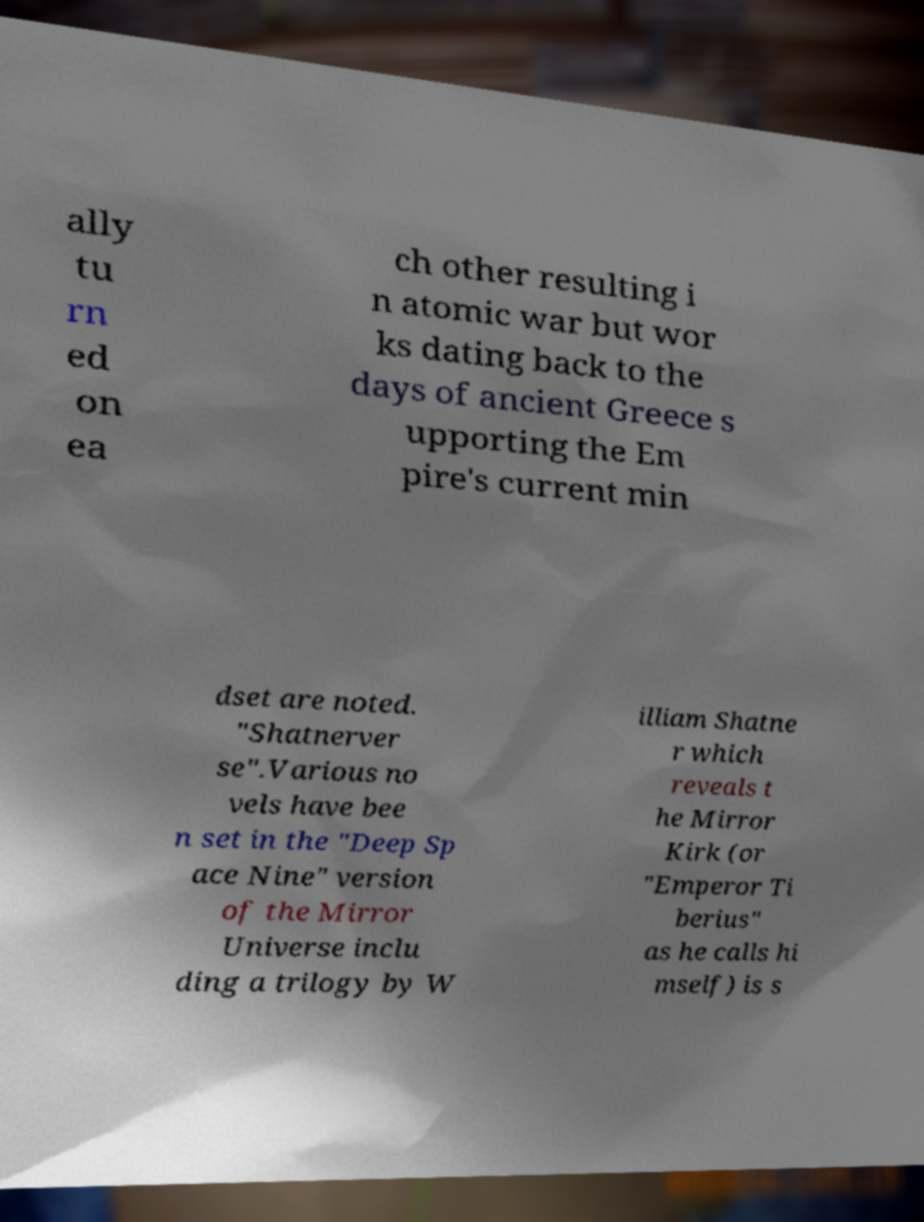Could you extract and type out the text from this image? ally tu rn ed on ea ch other resulting i n atomic war but wor ks dating back to the days of ancient Greece s upporting the Em pire's current min dset are noted. "Shatnerver se".Various no vels have bee n set in the "Deep Sp ace Nine" version of the Mirror Universe inclu ding a trilogy by W illiam Shatne r which reveals t he Mirror Kirk (or "Emperor Ti berius" as he calls hi mself) is s 